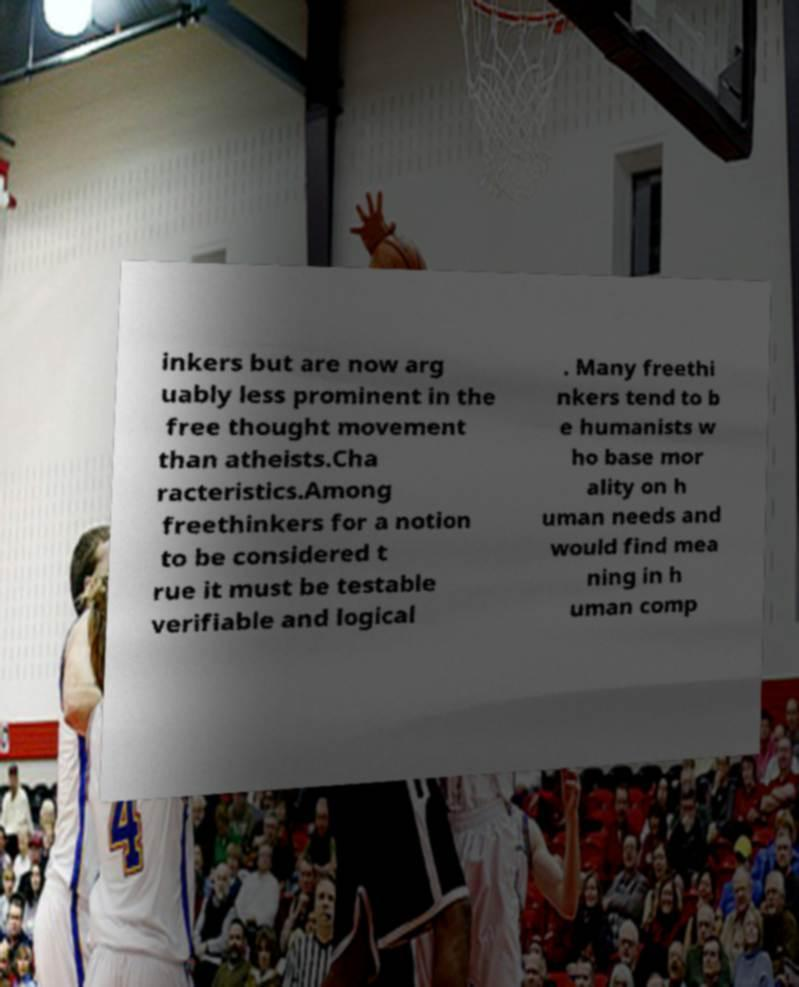Can you accurately transcribe the text from the provided image for me? inkers but are now arg uably less prominent in the free thought movement than atheists.Cha racteristics.Among freethinkers for a notion to be considered t rue it must be testable verifiable and logical . Many freethi nkers tend to b e humanists w ho base mor ality on h uman needs and would find mea ning in h uman comp 